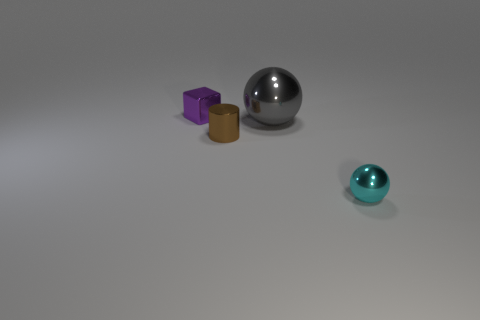Add 4 large yellow matte cylinders. How many objects exist? 8 Subtract all red spheres. Subtract all cyan cubes. How many spheres are left? 2 Subtract all cylinders. How many objects are left? 3 Add 3 cyan shiny balls. How many cyan shiny balls exist? 4 Subtract 0 blue cubes. How many objects are left? 4 Subtract all cylinders. Subtract all objects. How many objects are left? 2 Add 2 cyan spheres. How many cyan spheres are left? 3 